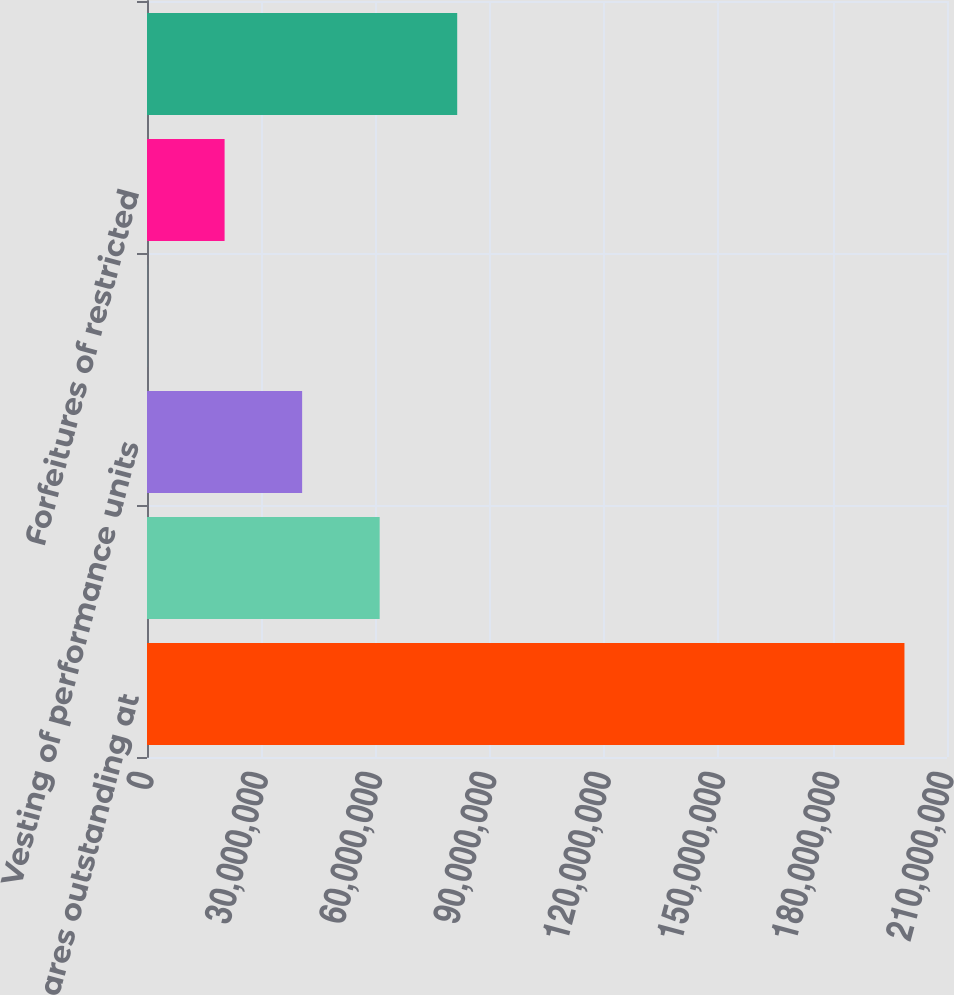Convert chart. <chart><loc_0><loc_0><loc_500><loc_500><bar_chart><fcel>Common shares outstanding at<fcel>Issuance of restricted stock<fcel>Vesting of performance units<fcel>Vesting of restricted stock<fcel>Forfeitures of restricted<fcel>Purchase of treasury stock (1)<nl><fcel>1.9883e+08<fcel>6.1076e+07<fcel>4.07224e+07<fcel>15141<fcel>2.03688e+07<fcel>8.14297e+07<nl></chart> 